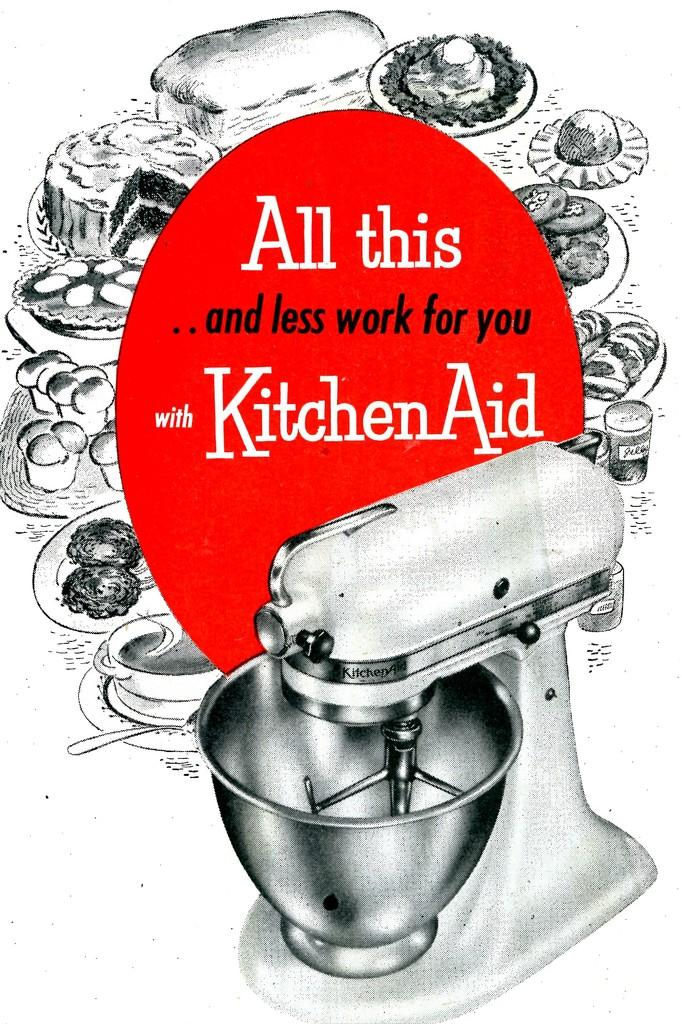Provide a one-sentence caption for the provided image. A mixer with a silver bowl is advertised by Kitchen Aid. 